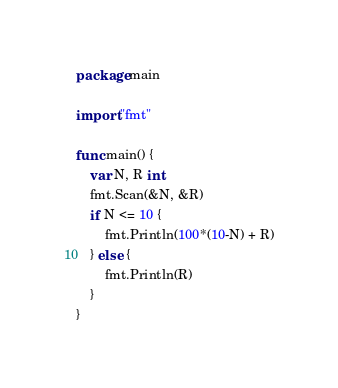<code> <loc_0><loc_0><loc_500><loc_500><_Go_>package main

import "fmt"

func main() {
	var N, R int
	fmt.Scan(&N, &R)
	if N <= 10 {
		fmt.Println(100*(10-N) + R)
	} else {
		fmt.Println(R)
	}
}
</code> 